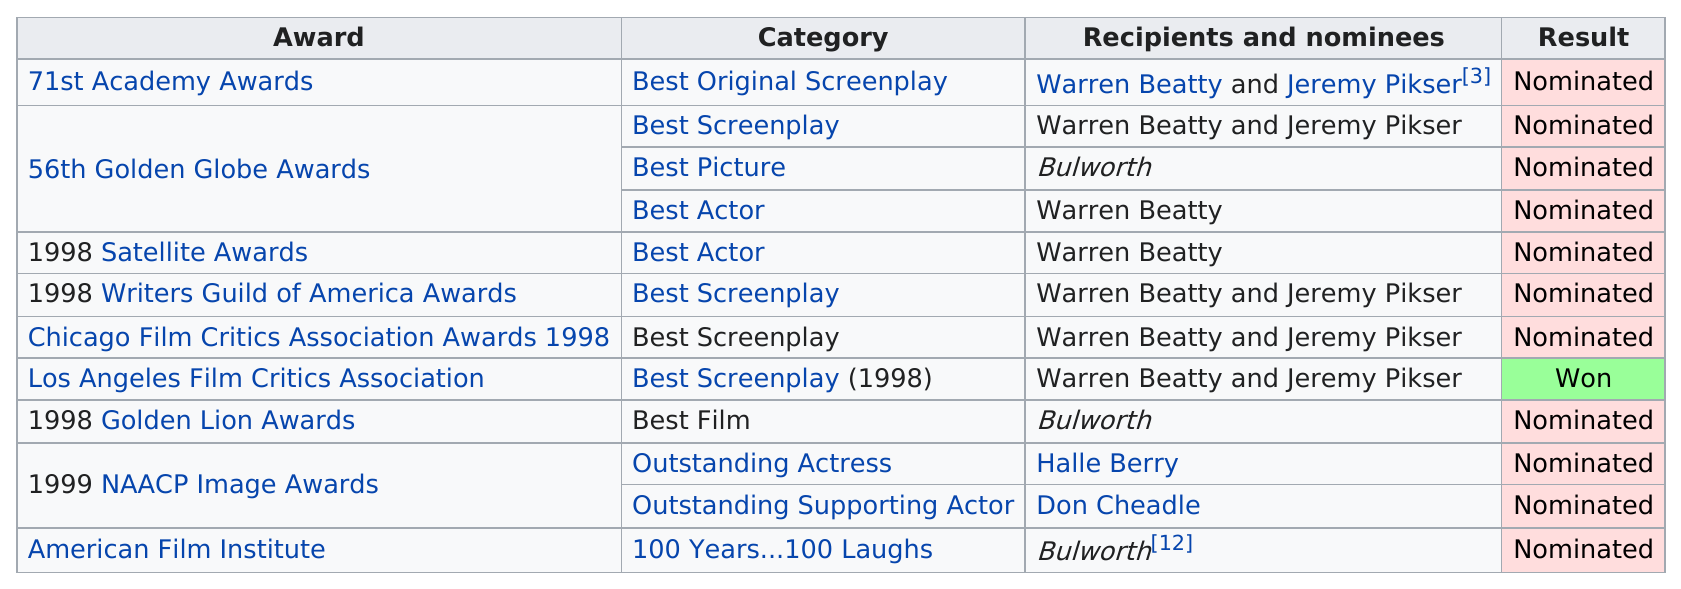Highlight a few significant elements in this photo. Warren Beatty and Jeremy Pikser won the Best Screenplay award together in 1998 for their work on the film. Warren Beatty was nominated for 7 awards. The 56th Golden Globe Awards received the most nominations, with a total of 56 in total. 